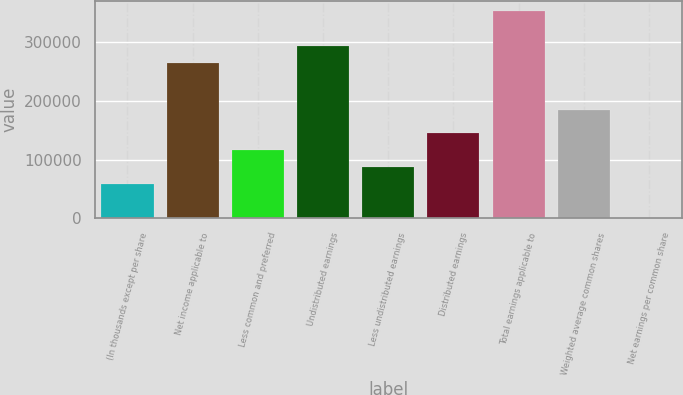Convert chart to OTSL. <chart><loc_0><loc_0><loc_500><loc_500><bar_chart><fcel>(In thousands except per share<fcel>Net income applicable to<fcel>Less common and preferred<fcel>Undistributed earnings<fcel>Less undistributed earnings<fcel>Distributed earnings<fcel>Total earnings applicable to<fcel>Weighted average common shares<fcel>Net earnings per common share<nl><fcel>58195.1<fcel>263791<fcel>116389<fcel>292888<fcel>87291.8<fcel>145485<fcel>351081<fcel>183844<fcel>1.58<nl></chart> 